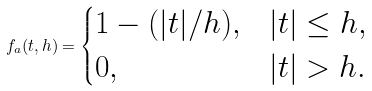<formula> <loc_0><loc_0><loc_500><loc_500>f _ { a } ( t , h ) = \begin{cases} 1 - ( | t | / h ) , & | t | \leq h , \\ 0 , & | t | > h . \end{cases}</formula> 